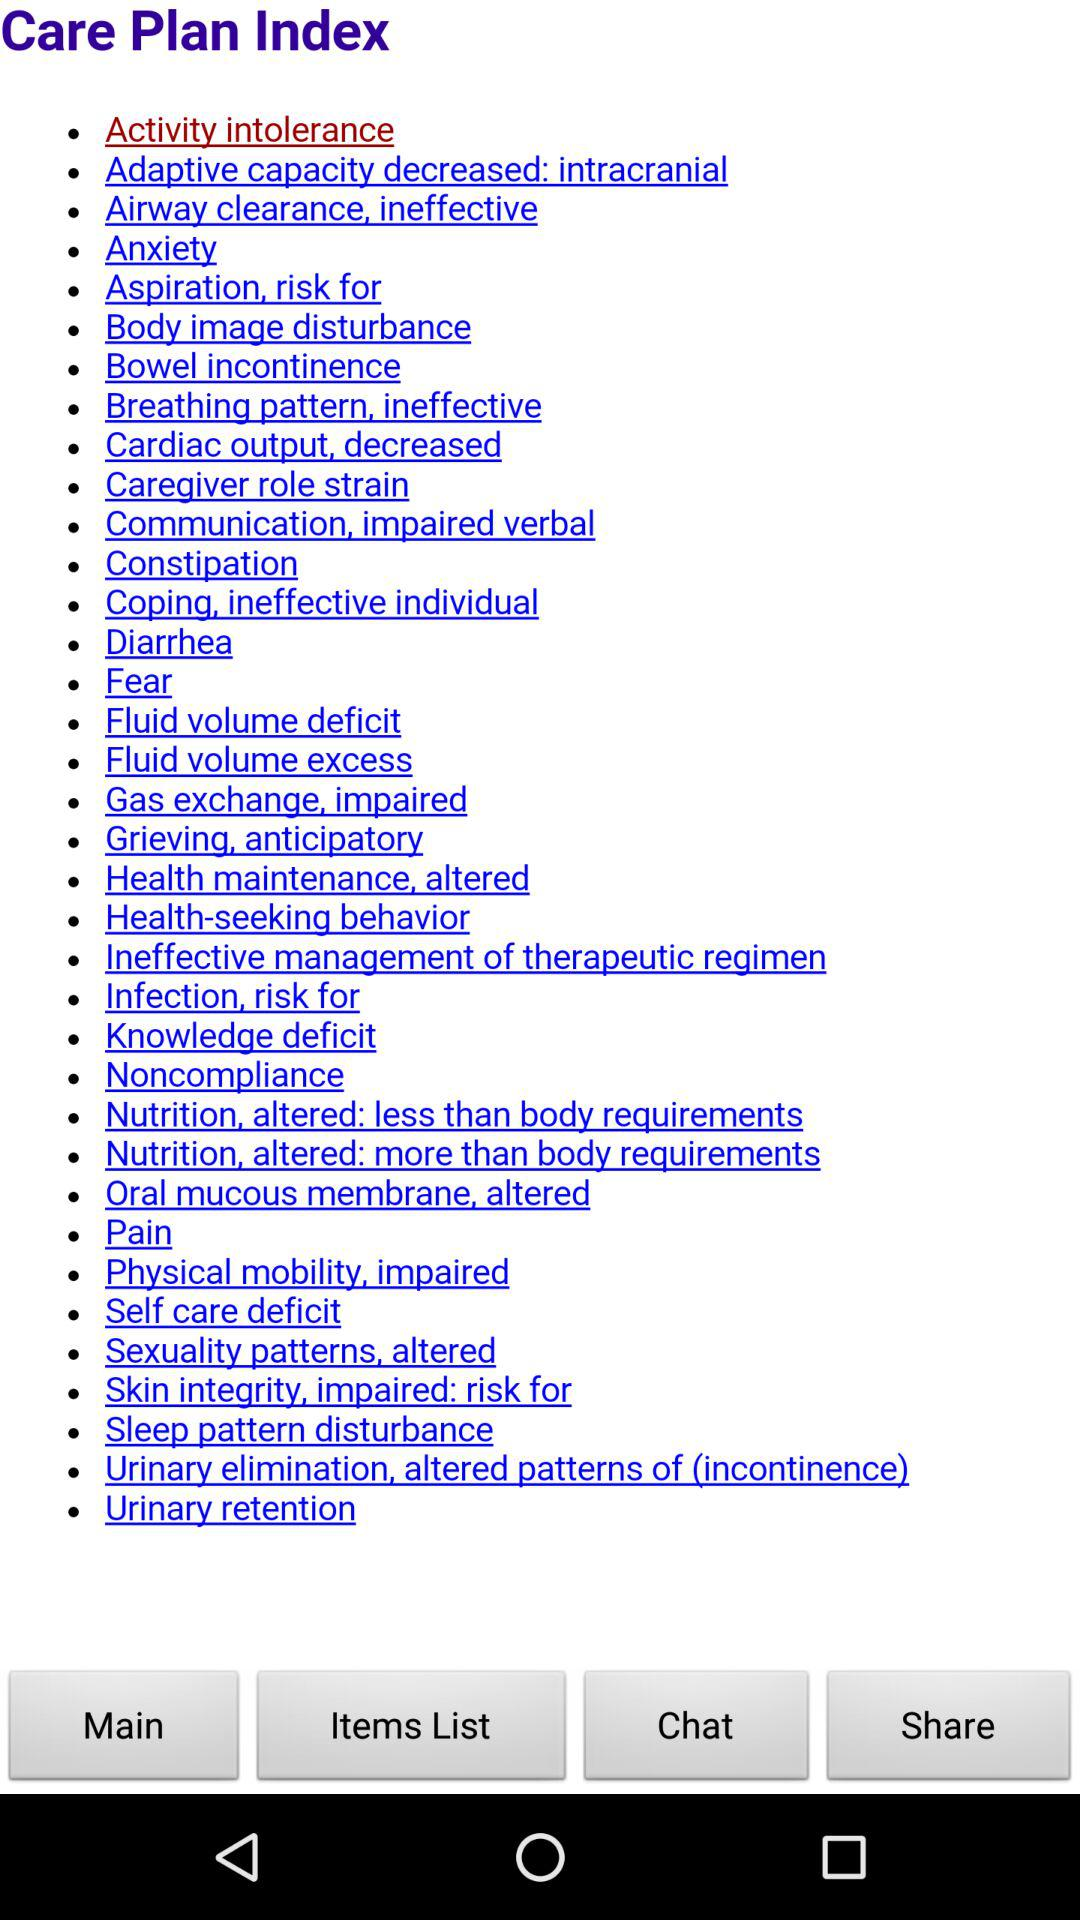What are the different care plan indices shown on the screen? The different care plan indices are "Activity intolerance", "Adaptive capacity decreased: intracranial", "Airway clearance, ineffective", "Anxiety", "Aspiration, risk for", "Body image disturbance", "Bowel incontinence", "Breathing pattern, ineffective", "Cardiac output, decreased", "Caregiver role strain", "Communication, impaired verbal", "Constipation", "Coping, ineffective individual", "Diarrhea", "Fear", "Fluid volume deficit", "Fluid volume excess", "Gas exchange, impaired", "Grieving, anticipatory", "Health maintenance, altered", "Health-seeking behavior", "Ineffective management of therapeutic regimen", "Infection, risk for", "Knowledge deficit", "Noncompliance", "Nutrition, altered: less than body requirements", "Nutrition, altered: more than body requirements", "Oral mucous membrane, altered", "Pain", "Physical mobility, impaired", "Self care deficit", "Sexuality patterns, altered", "Skin integrity, impaired: risk for", "Sleep pattern disturbance", "Urinary elimination, altered patterns of (incontinence)" and "Urinary retention". 